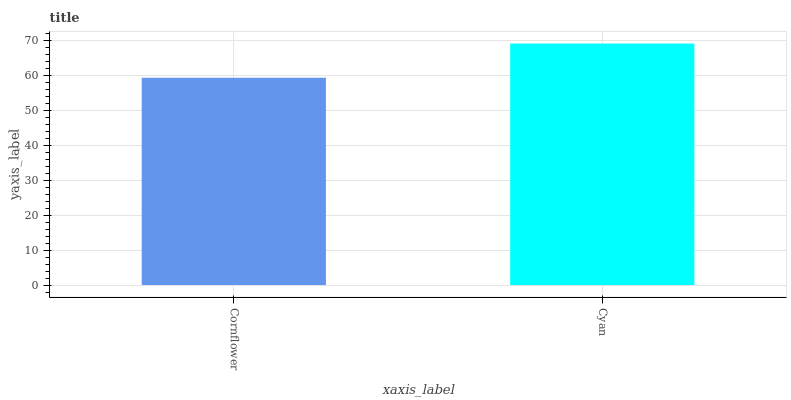Is Cornflower the minimum?
Answer yes or no. Yes. Is Cyan the maximum?
Answer yes or no. Yes. Is Cyan the minimum?
Answer yes or no. No. Is Cyan greater than Cornflower?
Answer yes or no. Yes. Is Cornflower less than Cyan?
Answer yes or no. Yes. Is Cornflower greater than Cyan?
Answer yes or no. No. Is Cyan less than Cornflower?
Answer yes or no. No. Is Cyan the high median?
Answer yes or no. Yes. Is Cornflower the low median?
Answer yes or no. Yes. Is Cornflower the high median?
Answer yes or no. No. Is Cyan the low median?
Answer yes or no. No. 